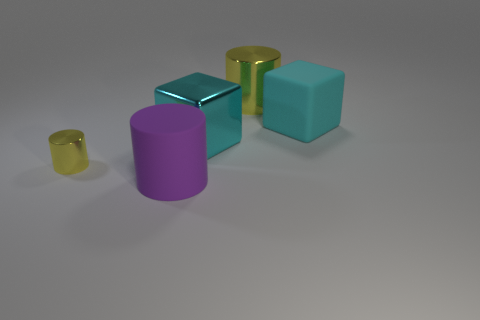Imagine these objects were part of a larger scene. What context could they be in? These objects could be part of a modern art installation that explores geometry and material interplay. The contrasting materials—metal, glass, and plastic—along with their varied colors, might be arranged to provoke thoughts about industrial design, the fusion of the functional with the aesthetic, or the integration of disparate elements in a cohesive visual composition. 